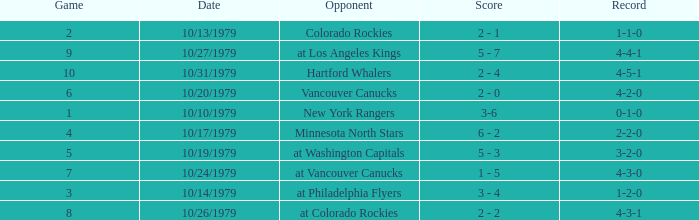Who is the opponent before game 5 with a 0-1-0 record? New York Rangers. 